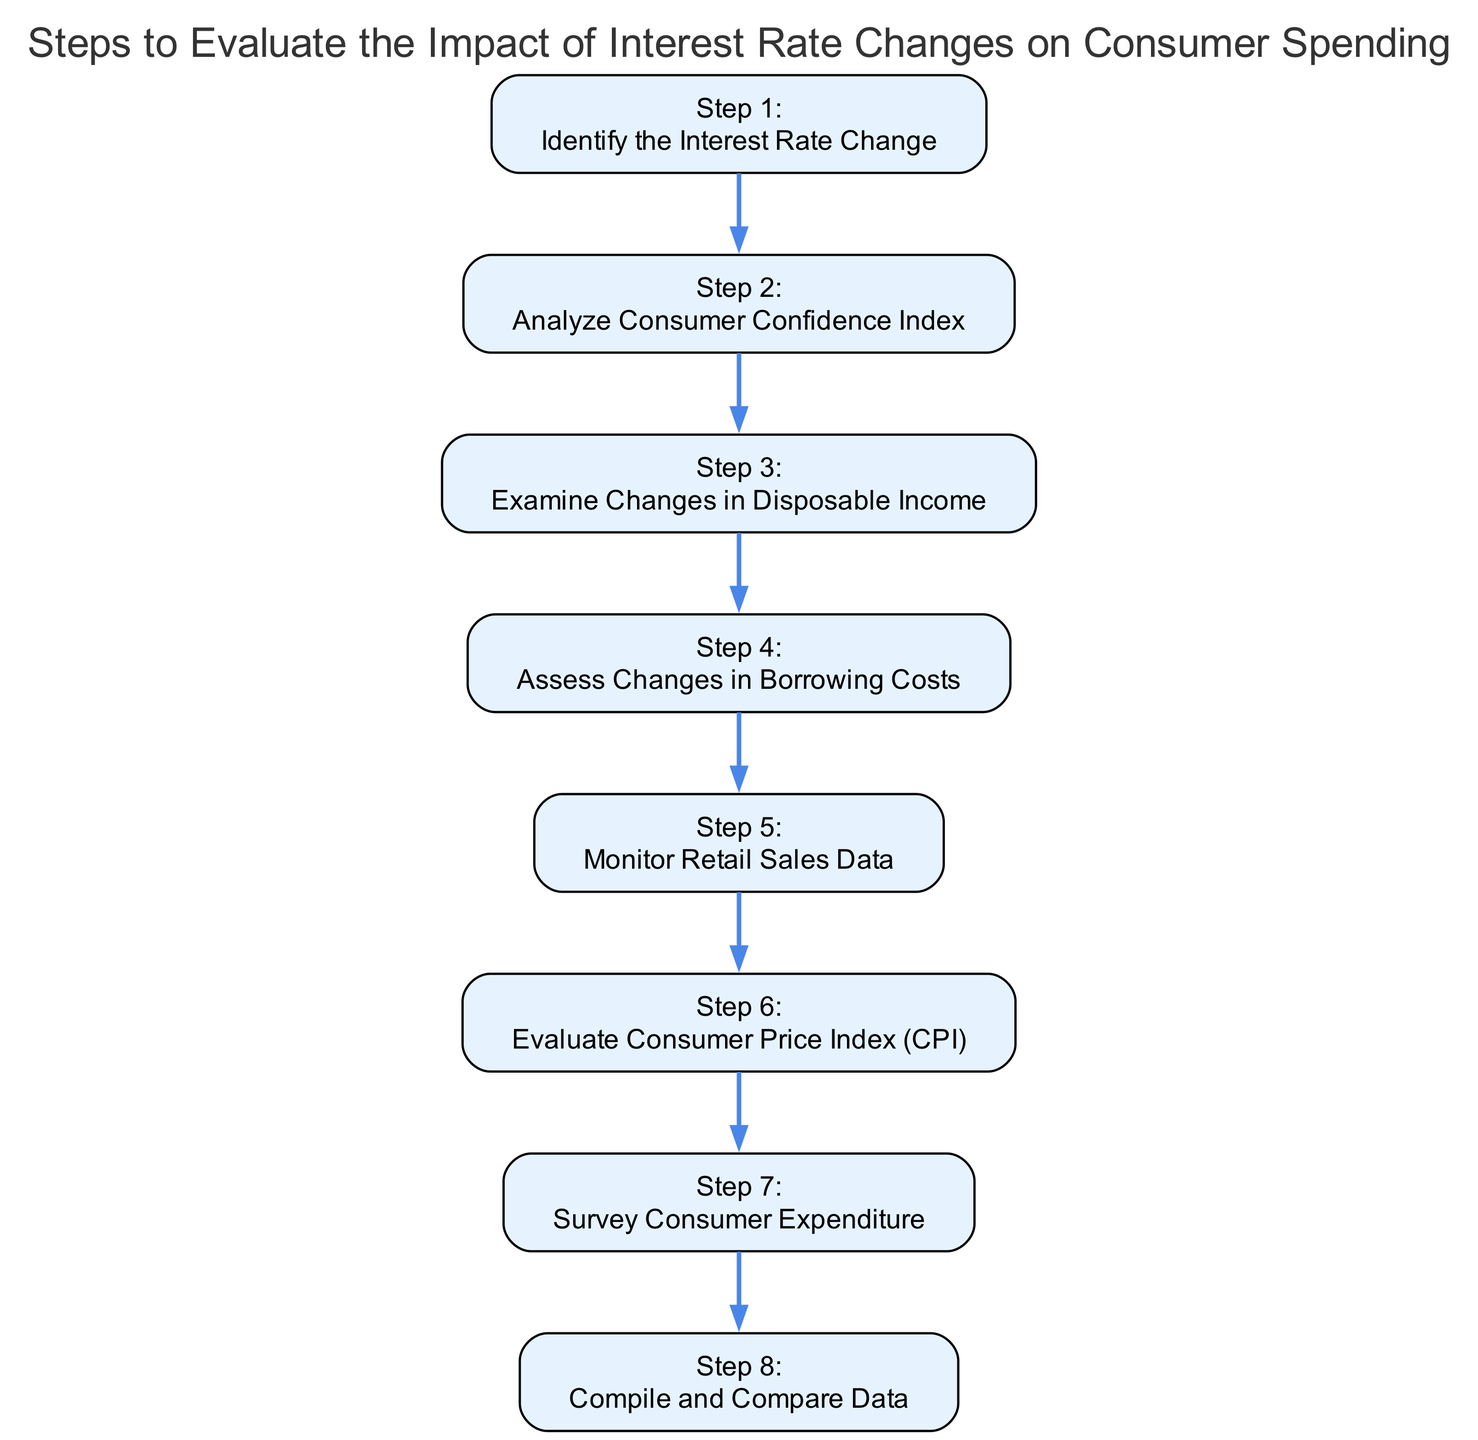What is the first step in evaluating the impact of interest rate changes? The first step as described in the diagram is to "Identify the Interest Rate Change."
Answer: Identify the Interest Rate Change How many steps are outlined in the process? The diagram outlines a total of eight steps, each detailing a different aspect of evaluating the impact of interest rate changes.
Answer: Eight steps What does step 4 focus on? Step 4 is focused on assessing "Changes in Borrowing Costs," which relates to how the interest rate change affects consumer loans, mortgages, and credit card costs.
Answer: Changes in Borrowing Costs What are the last two steps in the evaluation process? The last two steps are "Survey Consumer Expenditure" and "Compile and Compare Data," which involve gathering detailed insights into spending patterns and aggregating all data respectively.
Answer: Survey Consumer Expenditure, Compile and Compare Data Which two steps analyze consumer behavior sentiment after an interest rate change? The steps that analyze consumer behavior sentiment are "Analyze Consumer Confidence Index" (step 2) and "Monitor Retail Sales Data" (step 5), both focusing on different aspects of consumer attitudes and spending behavior.
Answer: Analyze Consumer Confidence Index, Monitor Retail Sales Data Why is "Evaluate Consumer Price Index (CPI)" an important step? This step is significant as it helps to analyze the inflationary effects of interest rate changes on consumer goods and services, providing a broader understanding of how prices may adjust post-change.
Answer: Inflationary effects on consumer goods and services What is the relationship between step 3 and step 4? Step 3 examines "Changes in Disposable Income," while step 4 assesses "Changes in Borrowing Costs." The relationship lies in understanding how disposable income affects borrowing decisions and consumer spending.
Answer: Changes in Disposable Income affects Changes in Borrowing Costs Which step focuses on the impact of interest rate changes on retail sales? The step that focuses on retail sales data in response to interest rate changes is step 5: "Monitor Retail Sales Data."
Answer: Monitor Retail Sales Data 